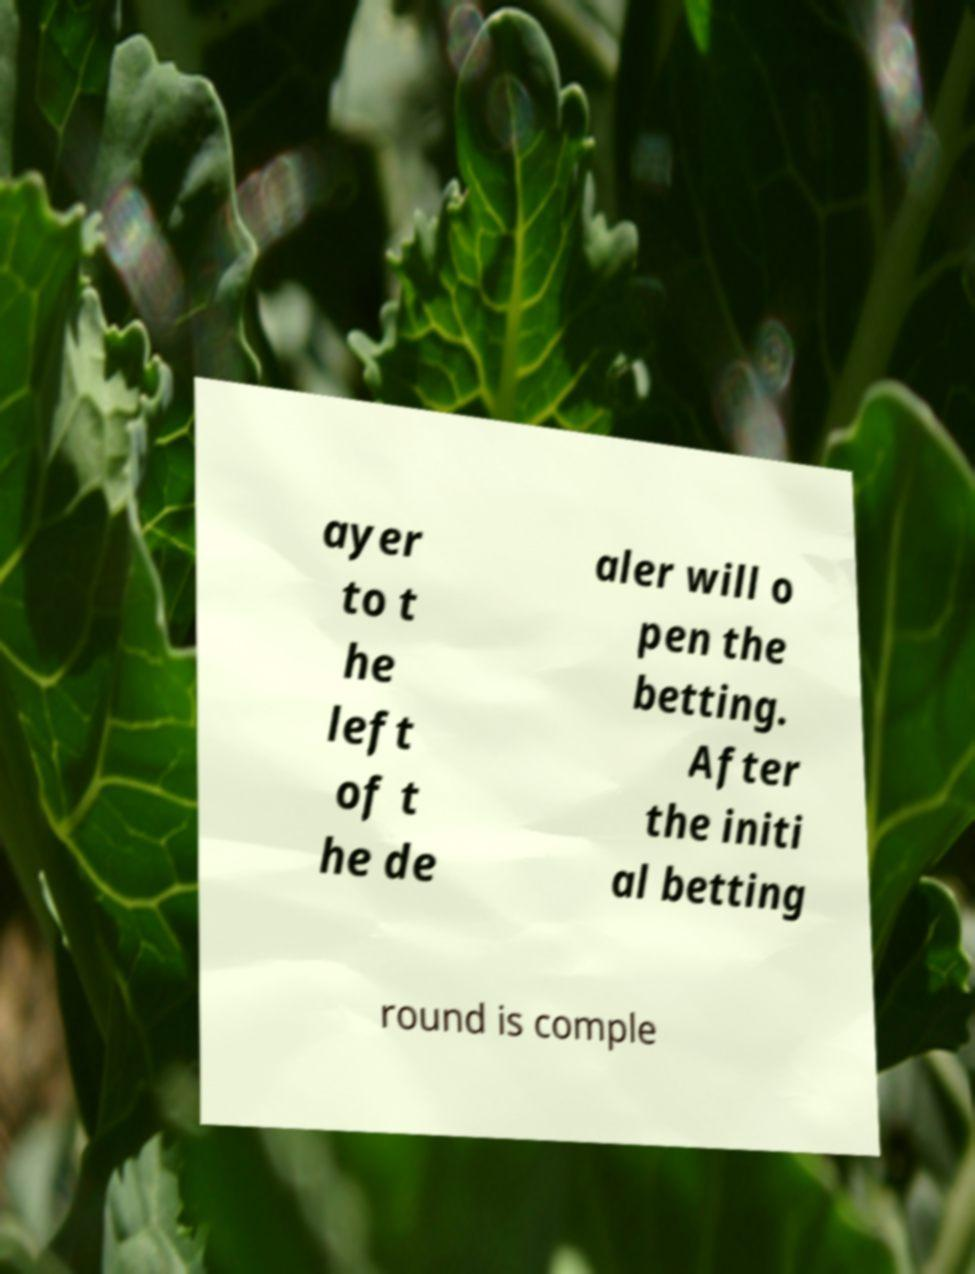Could you extract and type out the text from this image? ayer to t he left of t he de aler will o pen the betting. After the initi al betting round is comple 